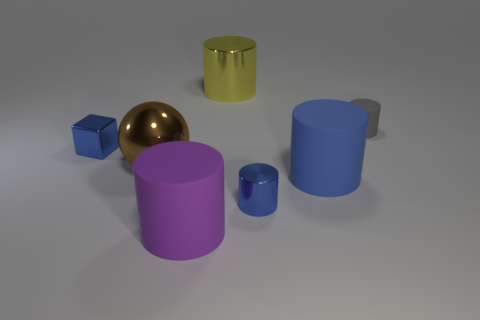There is a small shiny cube; is its color the same as the tiny cylinder that is in front of the tiny gray thing?
Give a very brief answer. Yes. There is a blue cylinder that is behind the blue shiny cylinder; what material is it?
Keep it short and to the point. Rubber. Are there any big matte things of the same color as the tiny block?
Your answer should be very brief. Yes. What is the color of the metal thing that is the same size as the shiny sphere?
Offer a terse response. Yellow. How many small things are gray metallic things or matte objects?
Give a very brief answer. 1. Is the number of brown metallic objects that are on the right side of the small gray cylinder the same as the number of big metal objects that are in front of the shiny cube?
Make the answer very short. No. What number of shiny balls have the same size as the yellow thing?
Give a very brief answer. 1. What number of blue things are either cubes or rubber spheres?
Ensure brevity in your answer.  1. Is the number of blue metal cylinders that are behind the small blue shiny block the same as the number of small yellow matte objects?
Keep it short and to the point. Yes. How big is the metallic thing to the left of the large brown metal sphere?
Your answer should be compact. Small. 